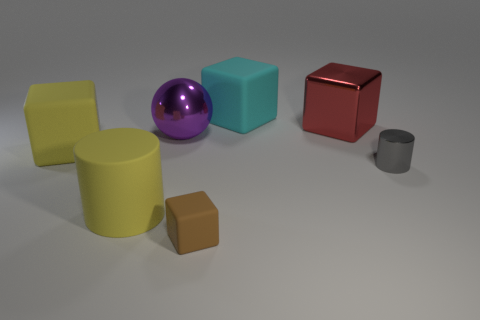Subtract all large yellow rubber cubes. How many cubes are left? 3 Add 1 balls. How many objects exist? 8 Subtract 3 blocks. How many blocks are left? 1 Subtract all blocks. How many objects are left? 3 Subtract all yellow blocks. How many blocks are left? 3 Subtract all gray spheres. Subtract all green cylinders. How many spheres are left? 1 Subtract all small cyan shiny blocks. Subtract all gray objects. How many objects are left? 6 Add 7 small shiny cylinders. How many small shiny cylinders are left? 8 Add 1 large metallic things. How many large metallic things exist? 3 Subtract 0 yellow spheres. How many objects are left? 7 